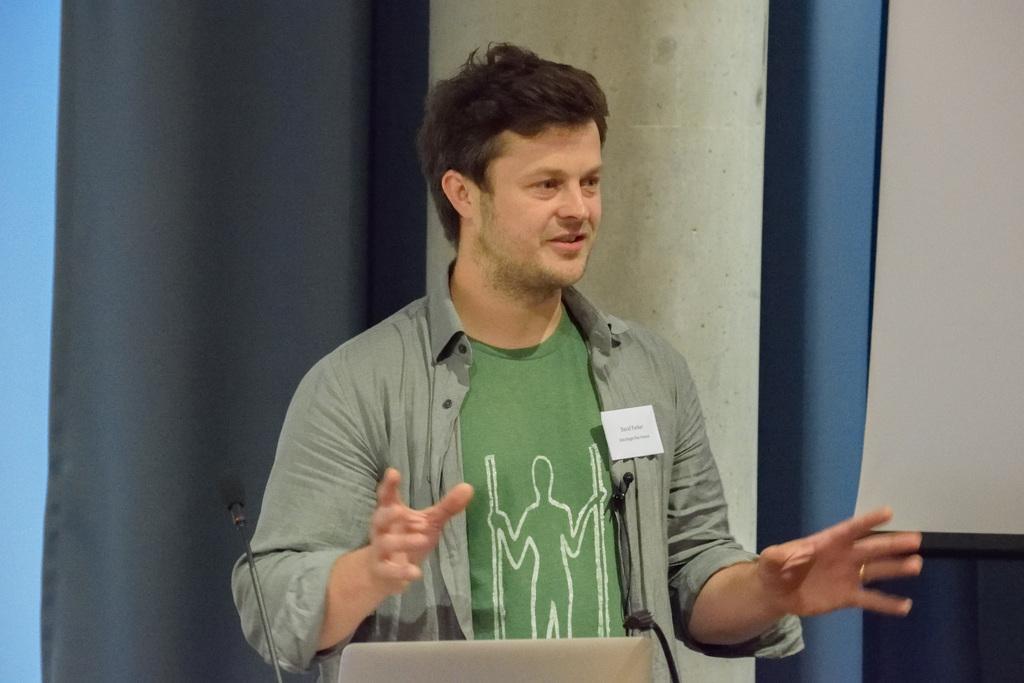How would you summarize this image in a sentence or two? In this image in the center there is one man who is talking, in front of him there are mike's. In the background there is curtain and wall. 